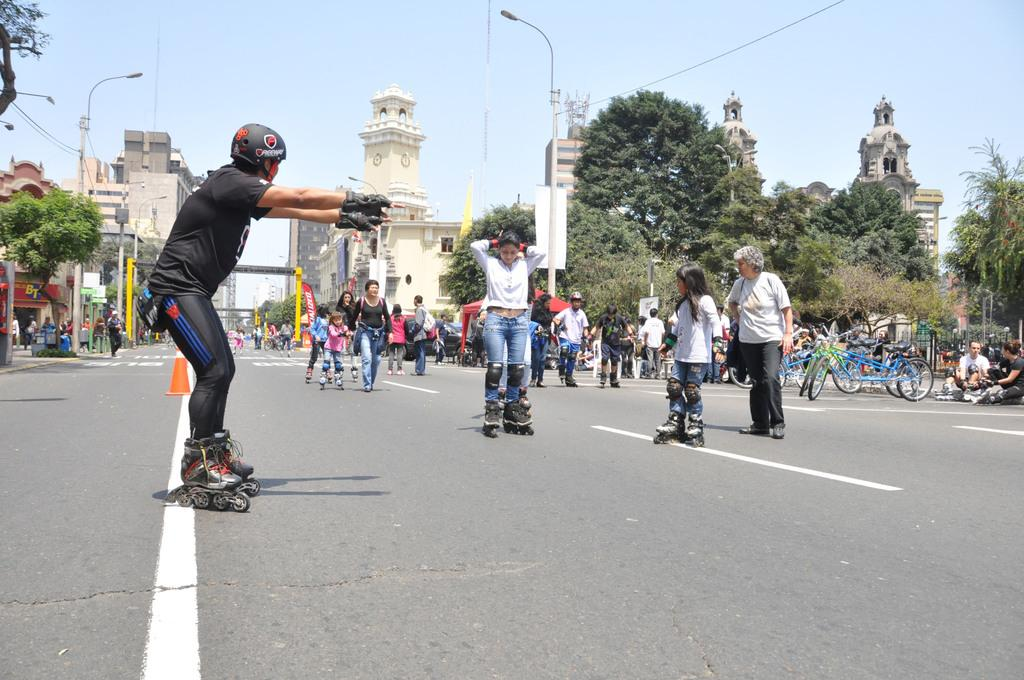What activity are the people in the image engaged in? The people in the image are doing skating on the road. Are there any other people present in the image? Yes, there are other people standing behind them. What can be seen in the background of the image? Trees and a building are visible in the background. What mode of transportation is parked on the road? Bicycles are parked on the road. What type of flower is being used to gain approval from the skaters in the image? There is no flower or approval-seeking activity present in the image. 